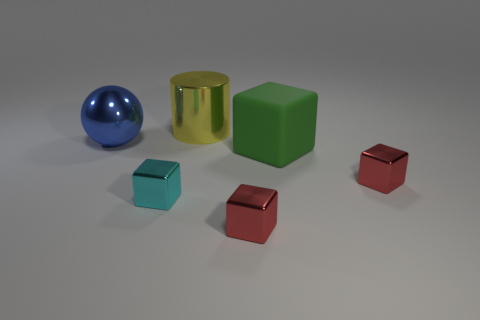Subtract all green matte cubes. How many cubes are left? 3 Add 1 yellow metallic cylinders. How many objects exist? 7 Subtract all green blocks. How many blocks are left? 3 Subtract 1 blocks. How many blocks are left? 3 Subtract all cyan metallic things. Subtract all metallic objects. How many objects are left? 0 Add 5 big matte things. How many big matte things are left? 6 Add 5 big blocks. How many big blocks exist? 6 Subtract 0 purple cubes. How many objects are left? 6 Subtract all cylinders. How many objects are left? 5 Subtract all yellow cubes. Subtract all green cylinders. How many cubes are left? 4 